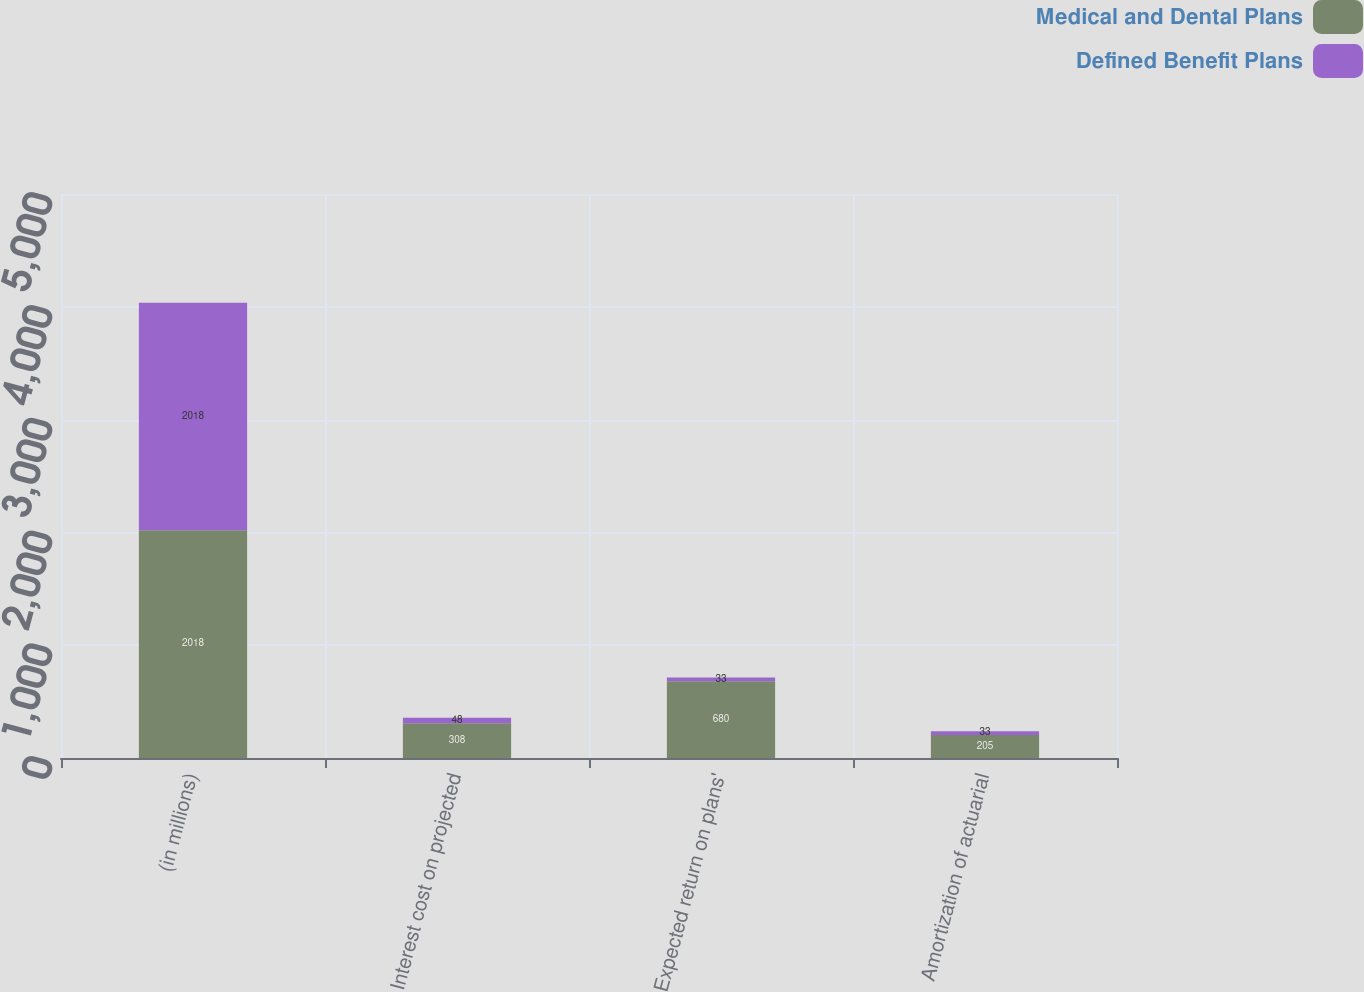Convert chart to OTSL. <chart><loc_0><loc_0><loc_500><loc_500><stacked_bar_chart><ecel><fcel>(in millions)<fcel>Interest cost on projected<fcel>Expected return on plans'<fcel>Amortization of actuarial<nl><fcel>Medical and Dental Plans<fcel>2018<fcel>308<fcel>680<fcel>205<nl><fcel>Defined Benefit Plans<fcel>2018<fcel>48<fcel>33<fcel>33<nl></chart> 